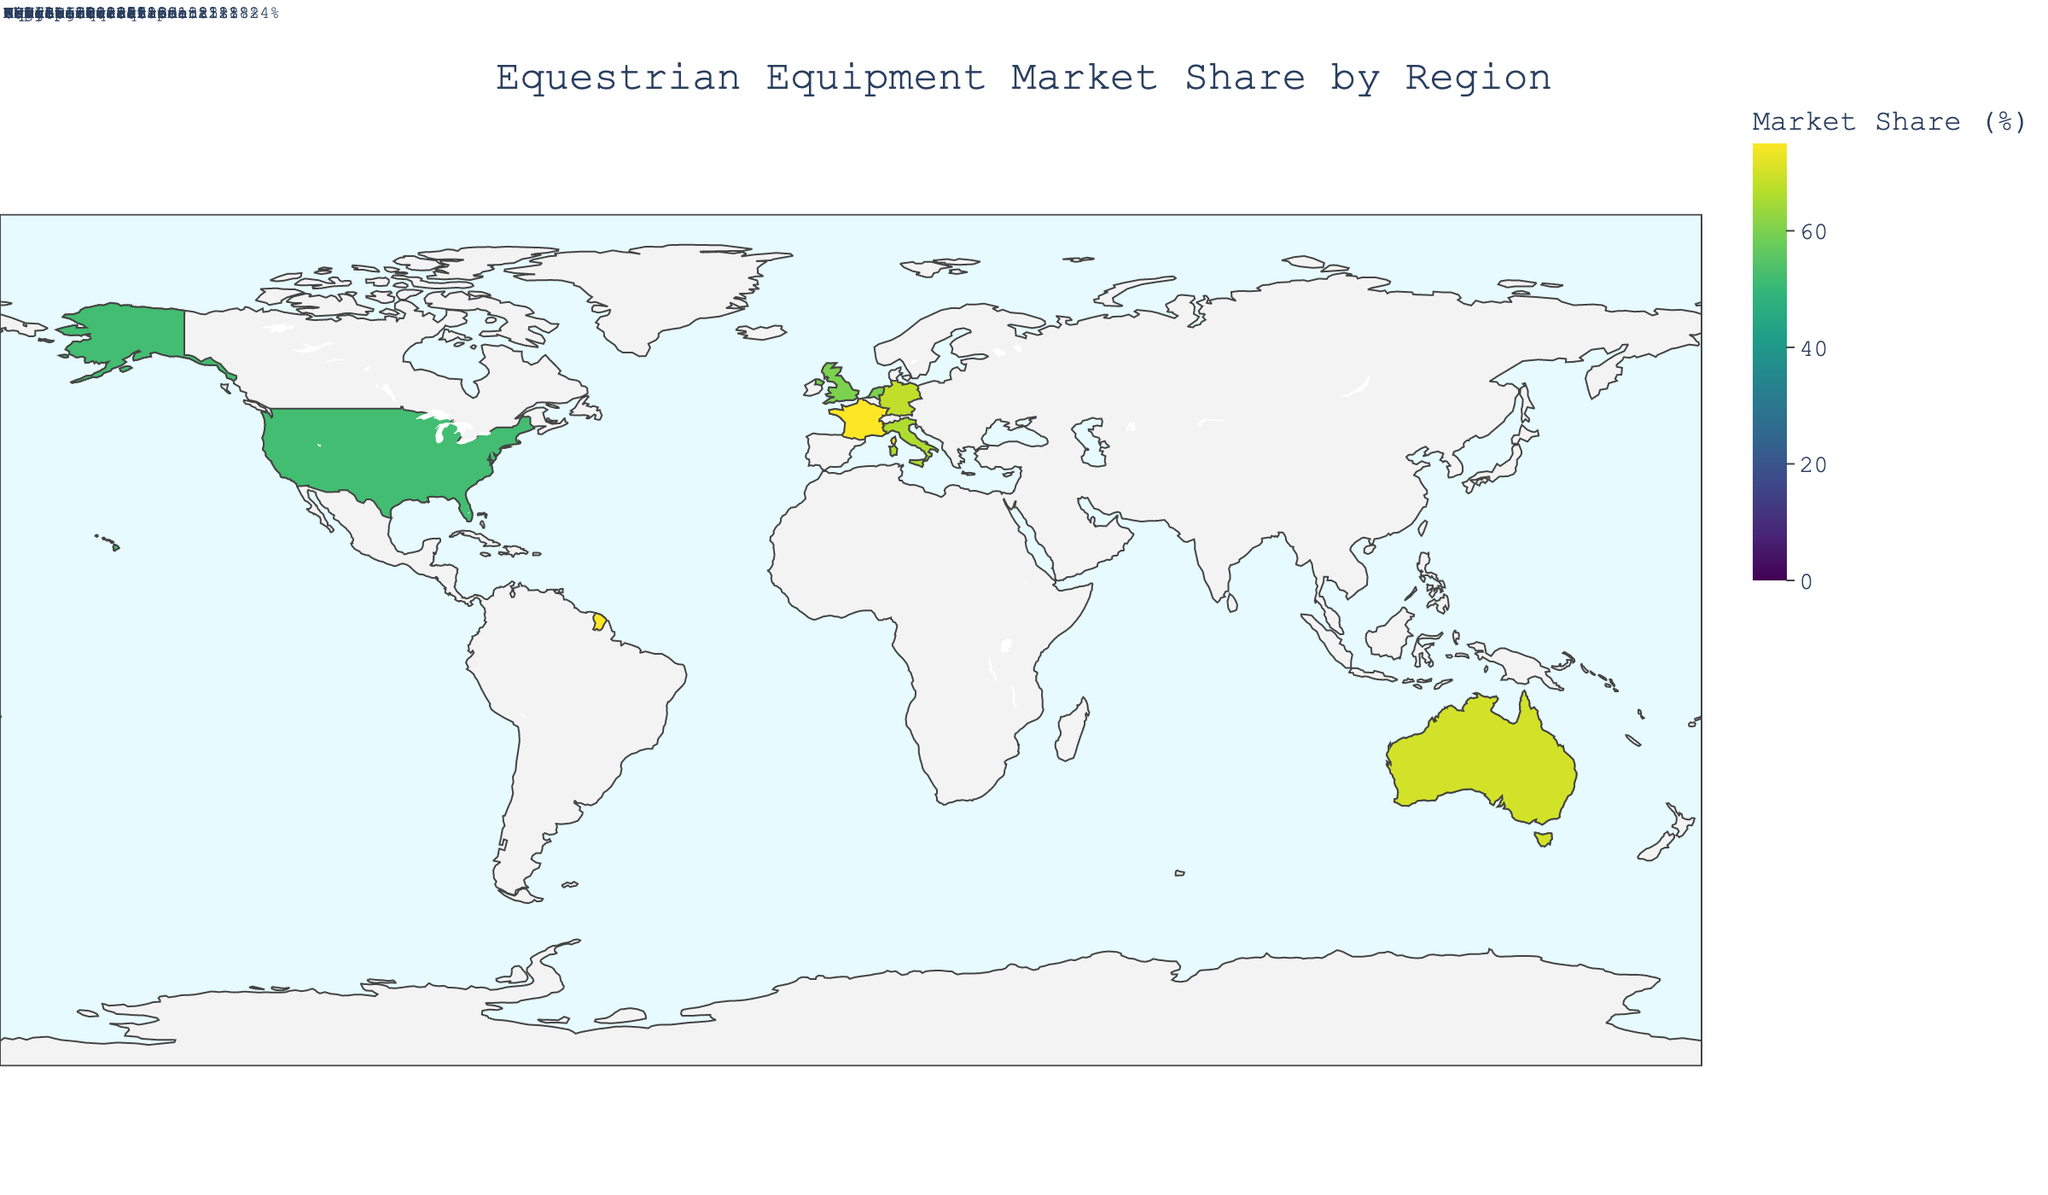What's the title of the figure? The title of the figure is typically shown at the top. In this case, the title is displayed as 'Equestrian Equipment Market Share by Region'.
Answer: Equestrian Equipment Market Share by Region Which region has the highest market share in equestrian equipment? To find the region with the highest market share, look at the color scale or annotations indicating percentage market shares. According to the data, France has the highest market share.
Answer: France What is the market share of Ariat International in the United States? Ariat International's market share in the United States is noted in the detailed annotations. Each manufacturer's market share in a given region is specifically listed. For Ariat International, the share is 18%.
Answer: 18% Which region has the smallest total market share? To determine the smallest total market share, compare the sum of shares in each region. The choropleth map would display this with variations in color intensity indicating lower values. Here, Italy has the smallest total market share.
Answer: Italy How does the market share of Toggi in the United Kingdom compare to that of Pikeur in Germany? Compare the individual market shares of Toggi and Pikeur, annotated as 20% and 28% respectively. Toggi has a smaller market share compared to Pikeur.
Answer: Toggi has a smaller market share than Pikeur What is the total market share for equestrian equipment manufacturers in the Netherlands? Add the market share percentages of all manufacturers listed for the Netherlands: Anky Technical Casuals (24%), Back on Track (20%), and Kavalkade (16%). The total is 24 + 20 + 16 = 60%.
Answer: 60% What is the average market share of the manufacturers listed in France? Sum the market shares of the manufacturers in France (CWD Sellier 30%, Equithème 25%, GPA Sport 20%) and divide by the number of manufacturers. (30 + 25 + 20) / 3 = 25%.
Answer: 25% Is there any manufacturer in Australia with a market share equal to or greater than CWD Sellier in France? CWD Sellier has a market share of 30%. In Australia, the manufacturers' shares are: Wintec (28%), EquiSafe (23%), and Tuff Rock (19%). None of these is equal to or greater than 30%.
Answer: No Which manufacturer has the highest market share in Germany? Look for the manufacturer annotations within Germany to identify the one with the highest share. Pikeur, with 28%, has the highest market share.
Answer: Pikeur How are the market shares distributed among manufacturers in the United Kingdom? The annotations provide specifics for each manufacturer: Shires Equestrian (25%), Toggi (20%), and Charles Owen (15%). Distribution can be observed through these percentages.
Answer: Shires Equestrian 25%, Toggi 20%, Charles Owen 15% 